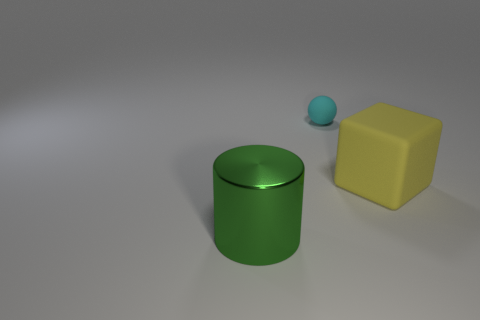What number of large cylinders have the same color as the matte cube?
Give a very brief answer. 0. What is the shape of the yellow thing that is the same size as the metallic cylinder?
Ensure brevity in your answer.  Cube. Is there a big yellow thing that has the same shape as the big green shiny thing?
Keep it short and to the point. No. What number of small red cylinders are the same material as the tiny cyan object?
Give a very brief answer. 0. Are the big object in front of the block and the large cube made of the same material?
Offer a terse response. No. Are there more green metal things left of the small cyan rubber ball than yellow cubes in front of the big yellow matte cube?
Ensure brevity in your answer.  Yes. There is a object that is the same size as the block; what is its material?
Ensure brevity in your answer.  Metal. What number of other objects are there of the same material as the tiny thing?
Provide a short and direct response. 1. Does the thing in front of the big yellow rubber cube have the same shape as the big object that is on the right side of the large metal cylinder?
Your answer should be very brief. No. Is the thing that is in front of the cube made of the same material as the big block right of the small cyan sphere?
Provide a succinct answer. No. 